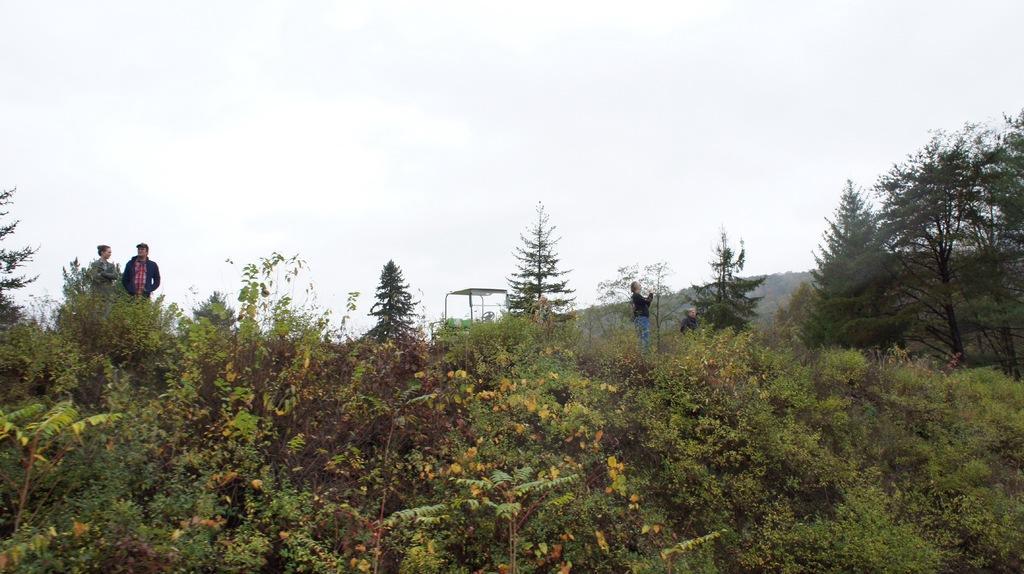Can you describe this image briefly? In this picture I can see there is a mountain and there are few people standing here on the mountain and there are plants, trees and the sky is clear. 